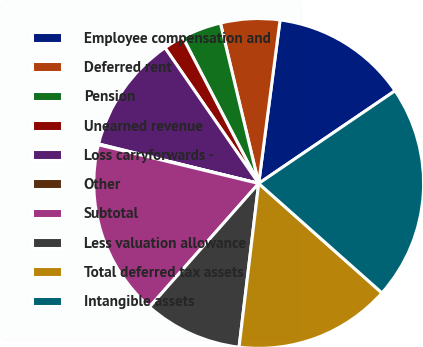<chart> <loc_0><loc_0><loc_500><loc_500><pie_chart><fcel>Employee compensation and<fcel>Deferred rent<fcel>Pension<fcel>Unearned revenue<fcel>Loss carryforwards -<fcel>Other<fcel>Subtotal<fcel>Less valuation allowance<fcel>Total deferred tax assets<fcel>Intangible assets<nl><fcel>13.43%<fcel>5.8%<fcel>3.9%<fcel>1.99%<fcel>11.53%<fcel>0.08%<fcel>17.25%<fcel>9.62%<fcel>15.34%<fcel>21.06%<nl></chart> 